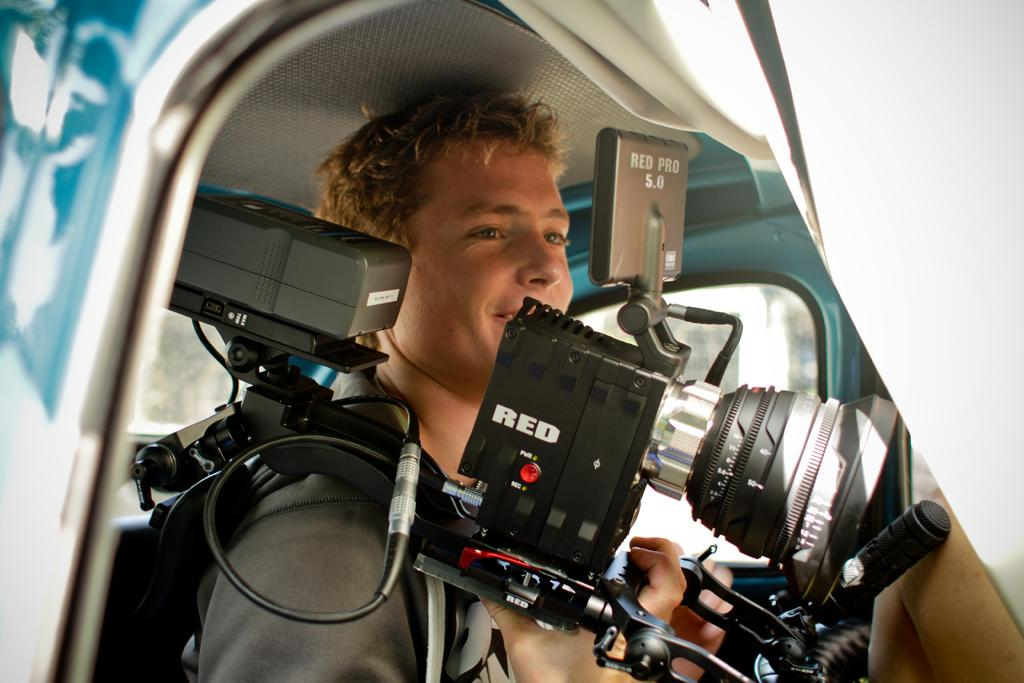Who is the main subject in the image? There is a man in the image. What is the man holding in the image? The man is carrying a camera. What is the man doing with the camera? The man is staring at the screen of the camera. How many loaves of bread are visible in the image? There are no loaves of bread present in the image. What type of babies can be seen playing in the image? There are no babies present in the image. 